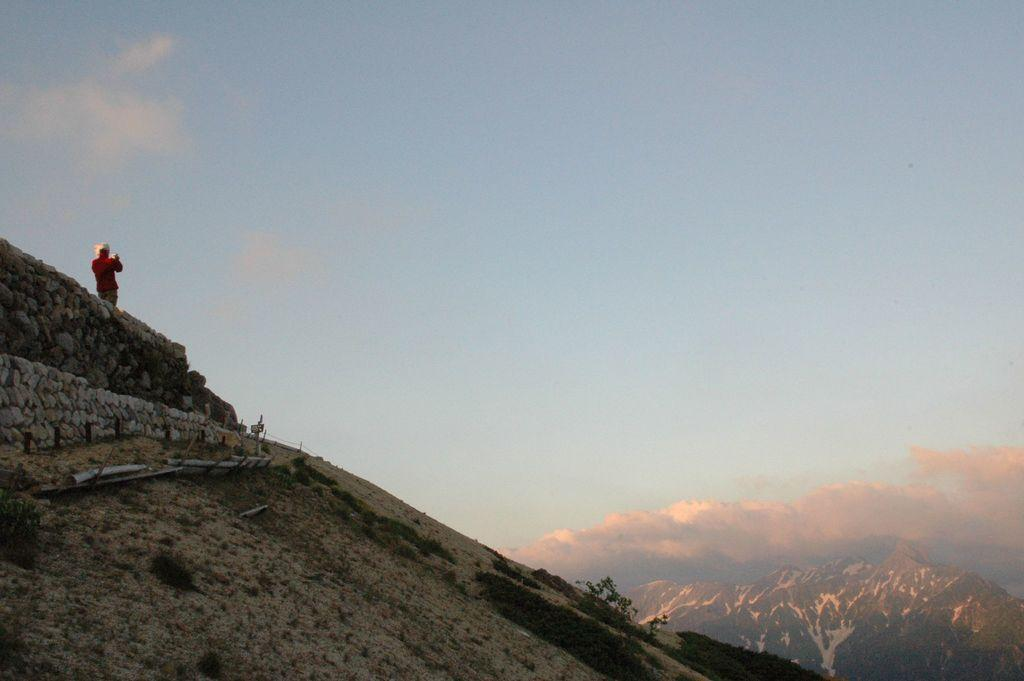What is located on the left side of the image? There is a person standing on the left side of the image. What is one of the main features in the image? There is a wall in the image. What type of vegetation is present in the image? There is grass and plants in the image. What can be seen in the background of the image? There are mountains visible in the background of the image. What is visible at the top of the image? The sky is visible at the top of the image. Where is the market located in the image? There is no market present in the image. How quiet is the person standing on the left side of the image? The image does not provide information about the person's volume or noise level. 